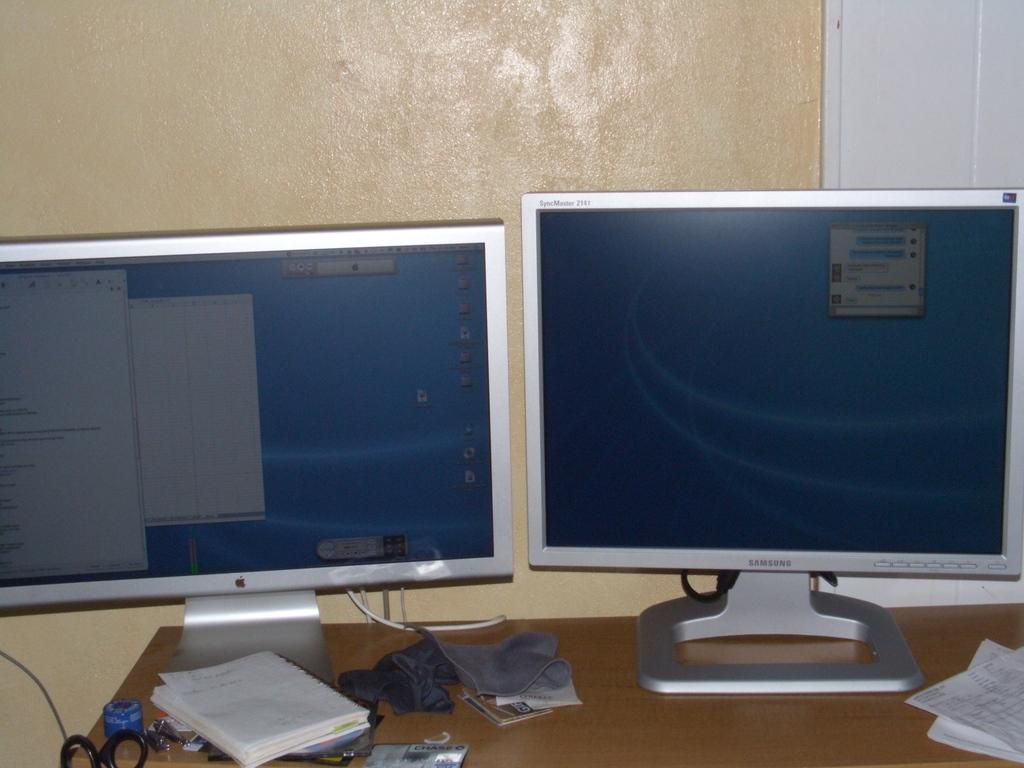<image>
Provide a brief description of the given image. an apple monitor and a samsung monitor on a desk 